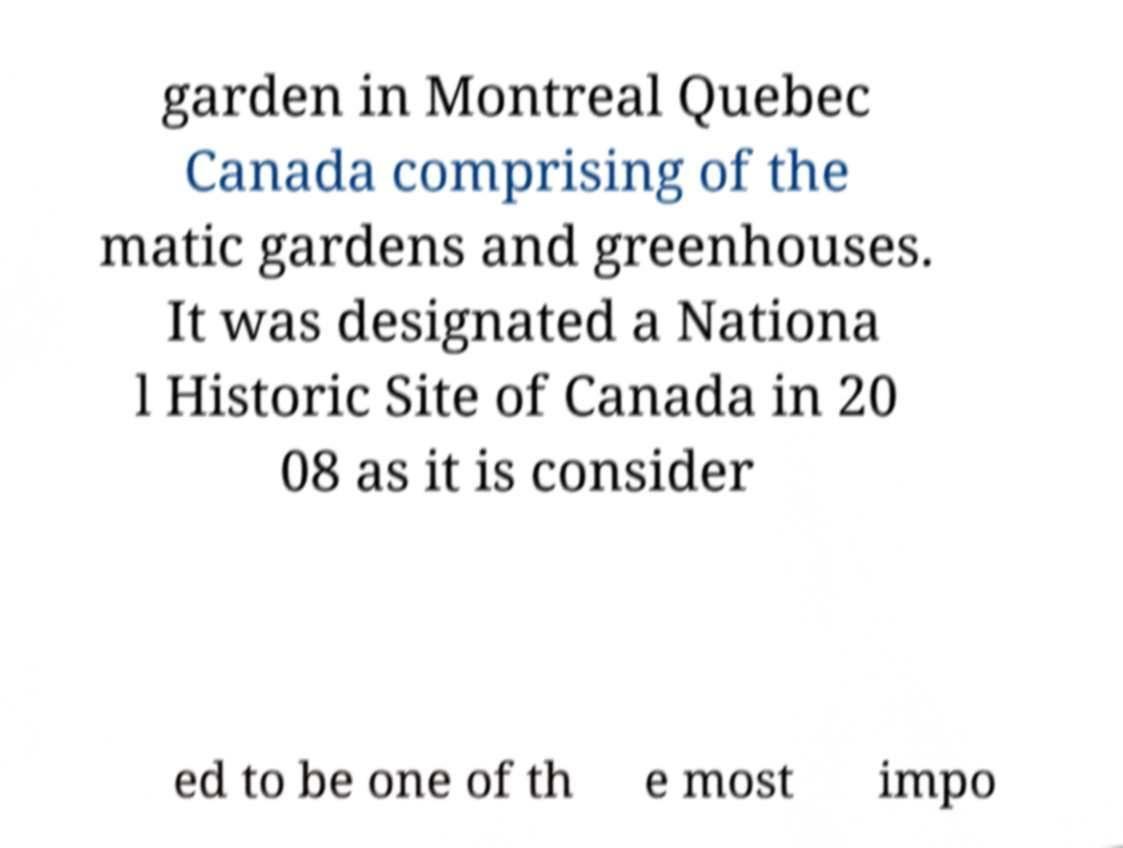Please read and relay the text visible in this image. What does it say? garden in Montreal Quebec Canada comprising of the matic gardens and greenhouses. It was designated a Nationa l Historic Site of Canada in 20 08 as it is consider ed to be one of th e most impo 